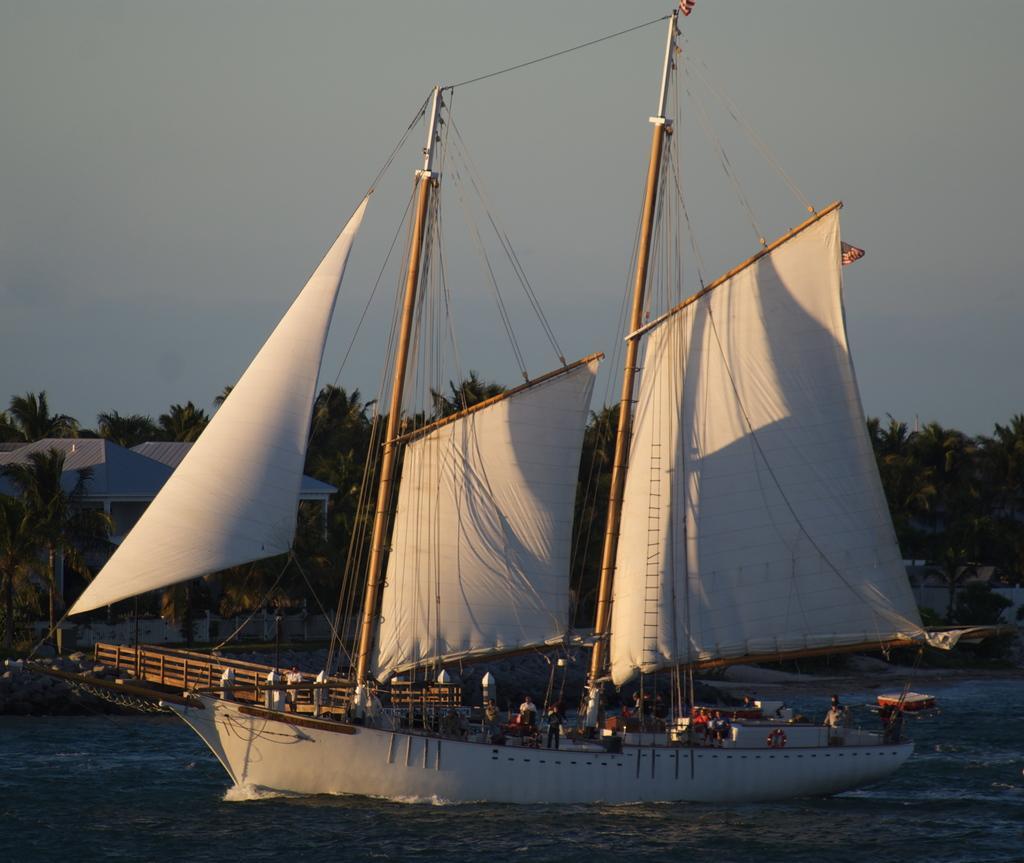In one or two sentences, can you explain what this image depicts? In this picture I can see a boat on the water and I can see few people standing in the boat. I can see couple of shelters, few trees in the back and a cloudy sky. 